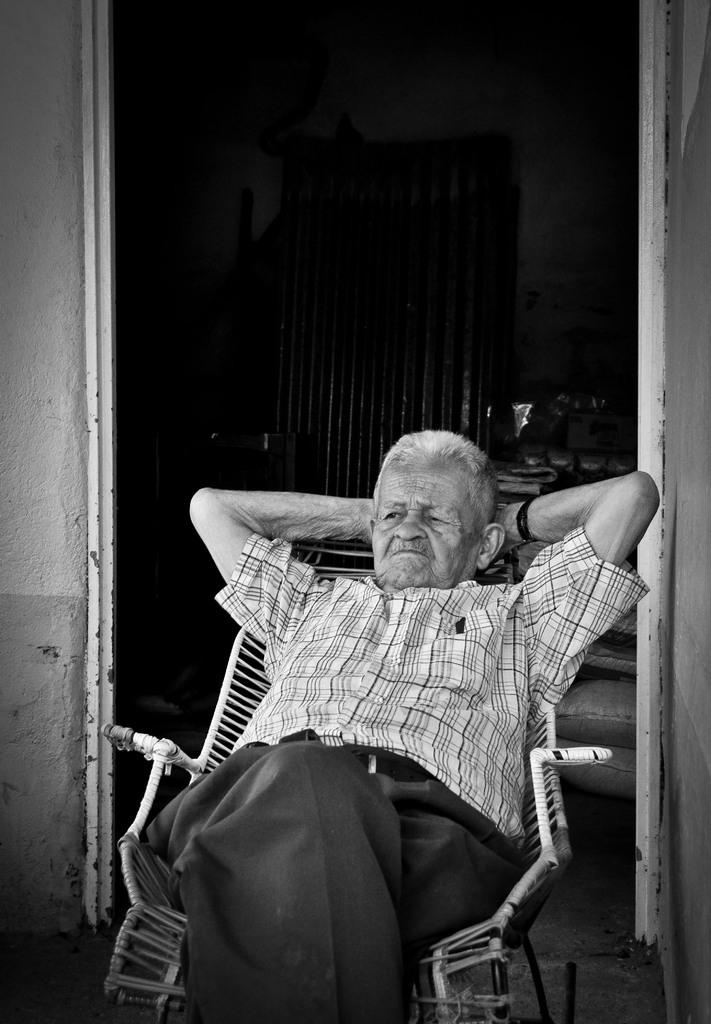What is the person in the image doing? The person is sitting on a chair in the image. What can be seen behind the person? There is a wall in the background of the image. Are there any walls visible on the sides of the image? Yes, there is a wall on the right side of the image and a wall on the left side of the image. What type of glue is being used to attach the rays to the wall in the image? There are no rays or glue present in the image; it only features a person sitting on a chair and walls in the background and on the sides. 